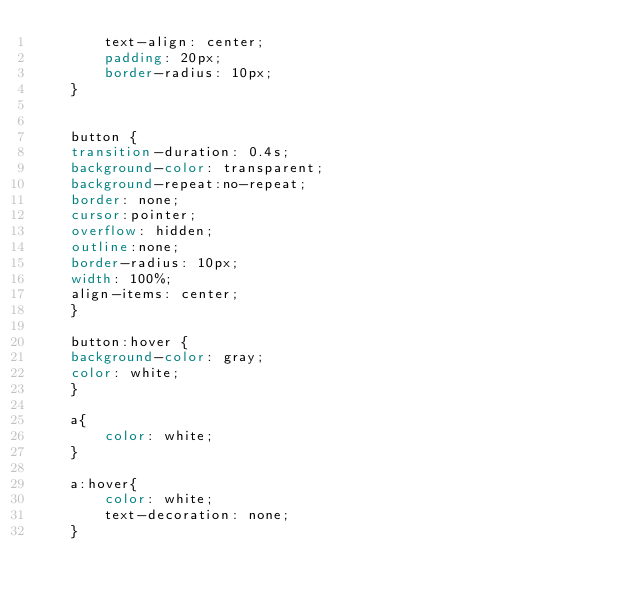<code> <loc_0><loc_0><loc_500><loc_500><_CSS_>        text-align: center;
        padding: 20px;
        border-radius: 10px;
    }


    button {
    transition-duration: 0.4s;
    background-color: transparent;
    background-repeat:no-repeat;
    border: none;
    cursor:pointer;
    overflow: hidden;
    outline:none;
    border-radius: 10px;
    width: 100%;
    align-items: center;
    }

    button:hover {
    background-color: gray;
    color: white;
    }

    a{
        color: white;
    }

    a:hover{
        color: white;
        text-decoration: none;
    }</code> 